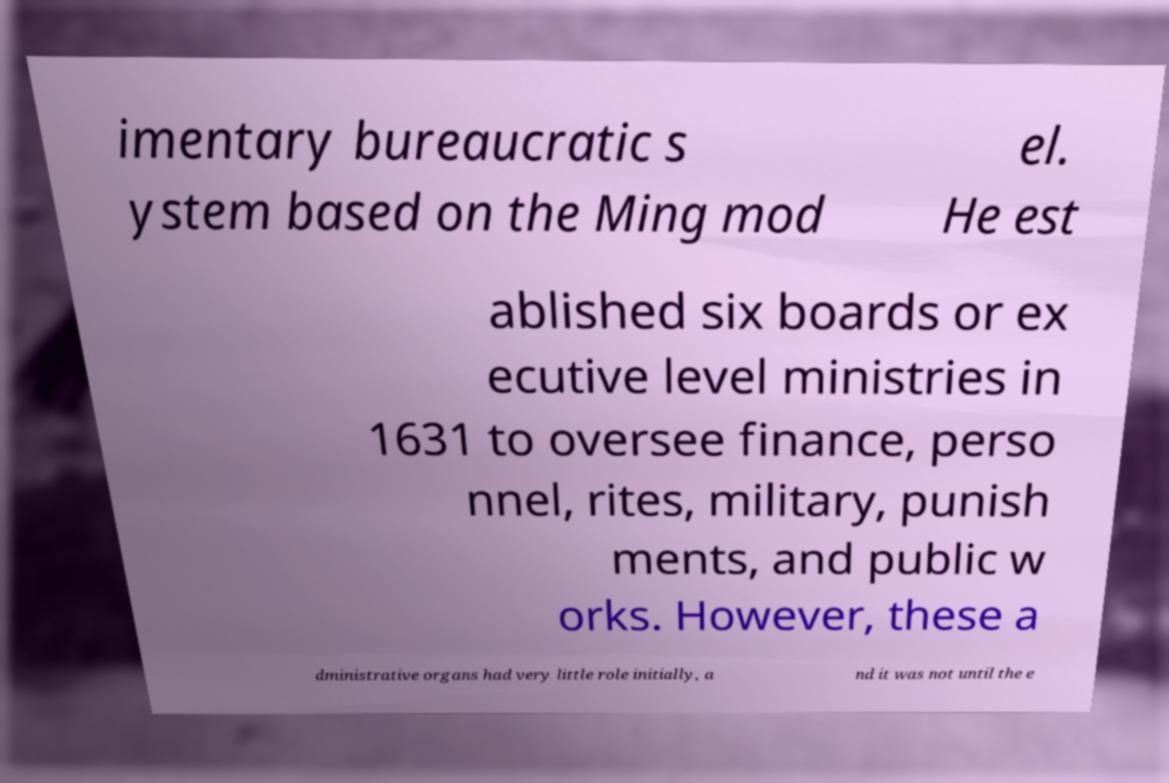Can you accurately transcribe the text from the provided image for me? imentary bureaucratic s ystem based on the Ming mod el. He est ablished six boards or ex ecutive level ministries in 1631 to oversee finance, perso nnel, rites, military, punish ments, and public w orks. However, these a dministrative organs had very little role initially, a nd it was not until the e 